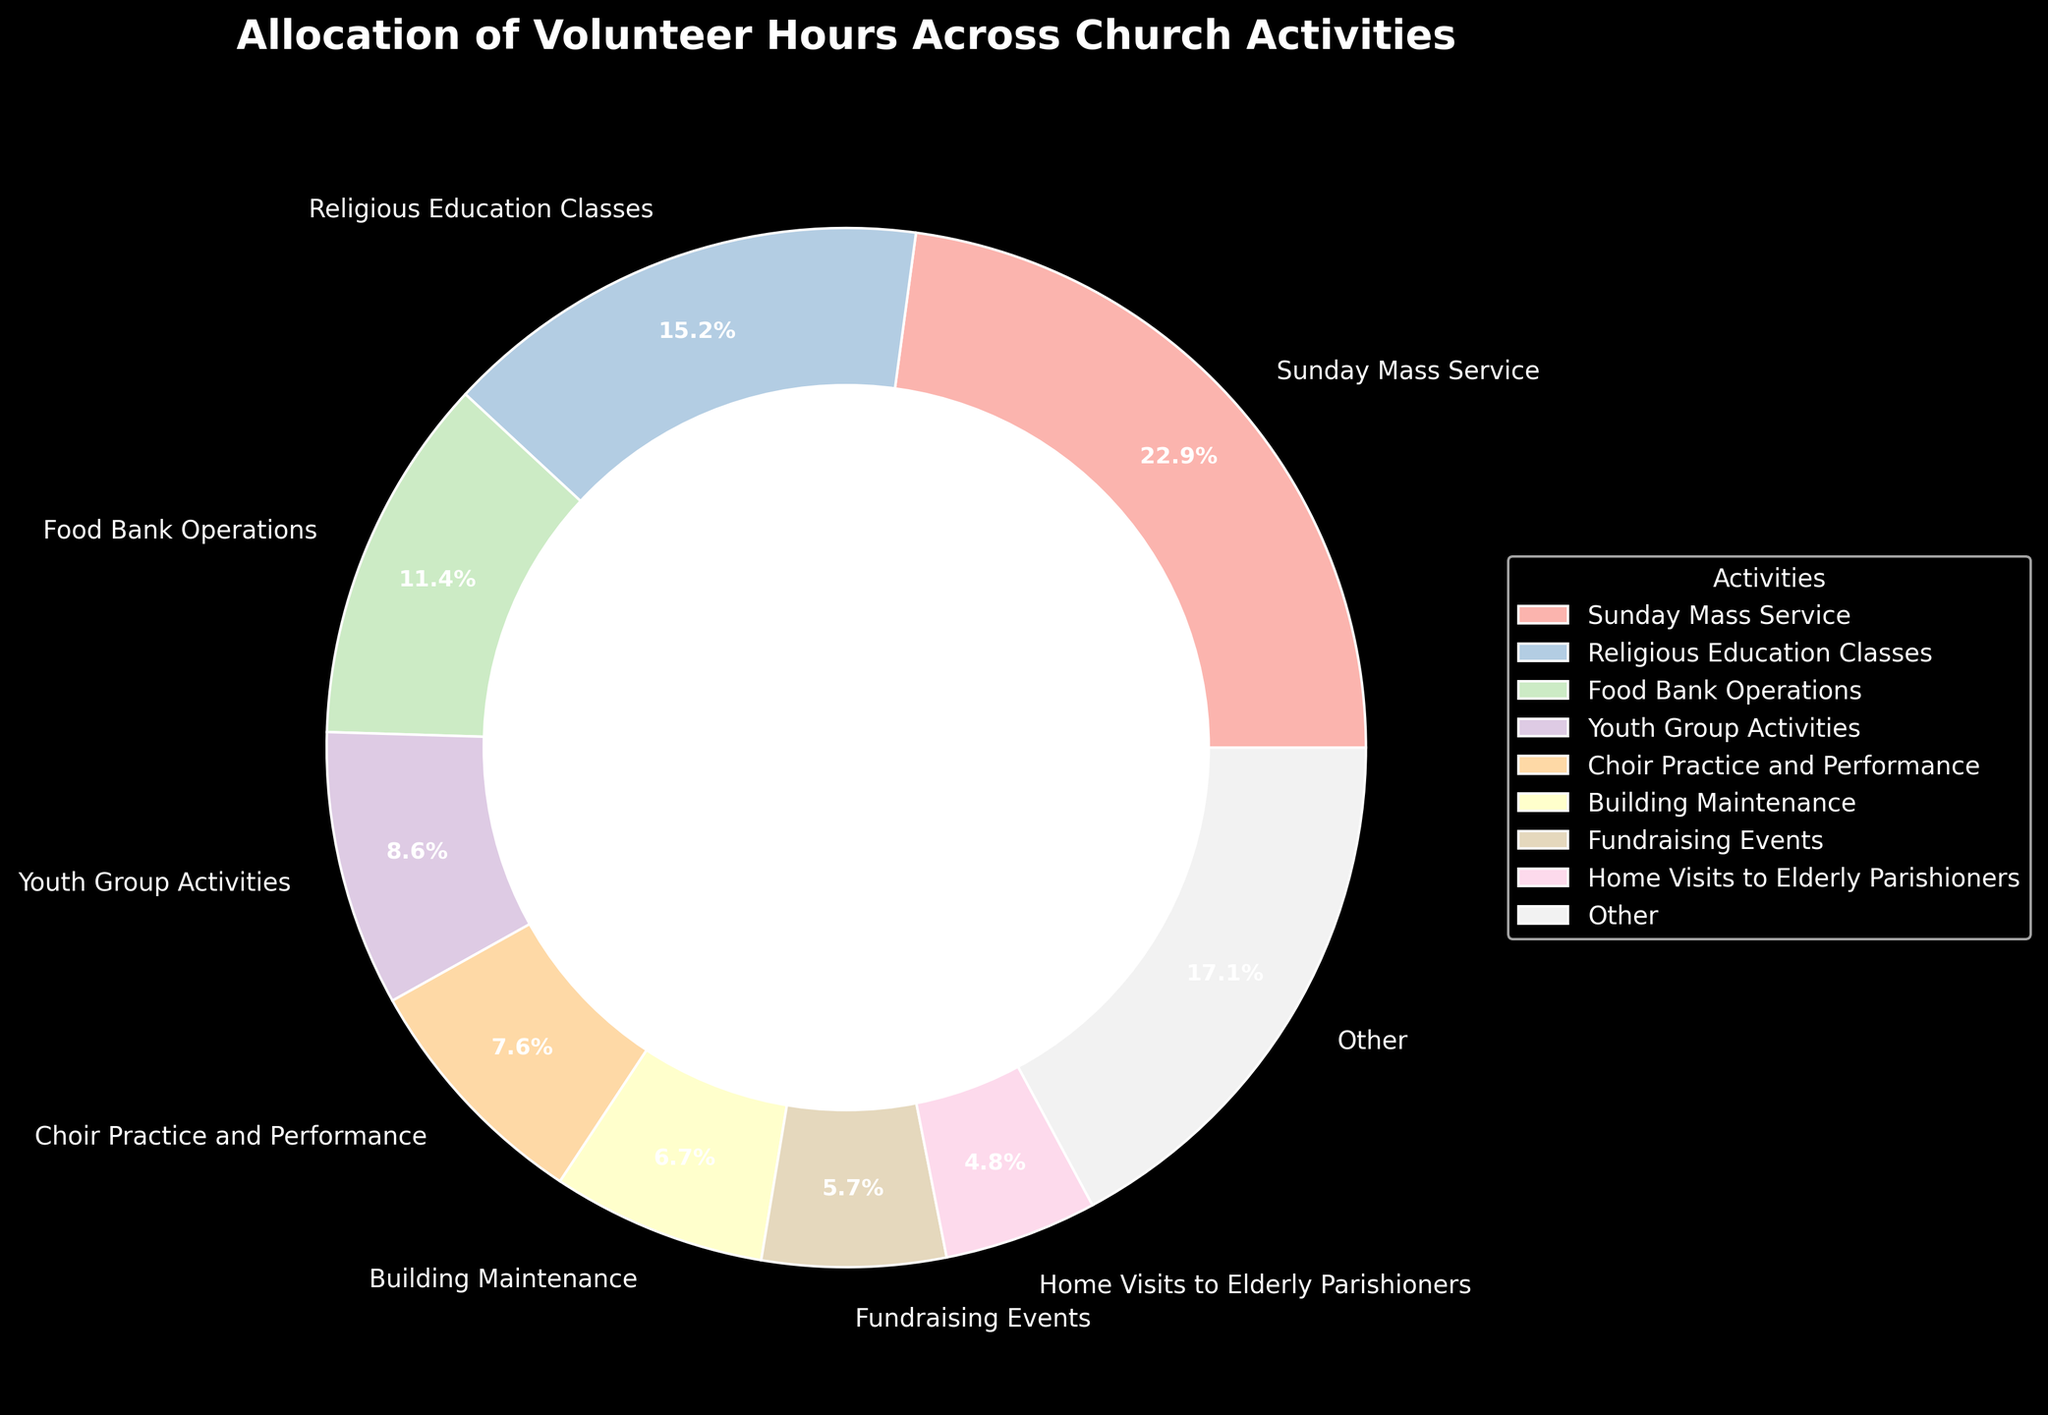Which activity receives the highest allocation of volunteer hours? By looking at the chart, the largest segment of the pie chart indicates the activity with the highest allocation.
Answer: Sunday Mass Service What percentage of total volunteer hours is allocated to Food Bank Operations? By referring to the label on the Food Bank Operations segment, we can directly see the percentage.
Answer: 12.8% How many activities are included under the 'Other' category? The 'Other' category aggregates the hours of all activities beyond the top 8. We check the number of activities listed in the legend and subtract 8.
Answer: 8 activities What is the combined percentage of volunteer hours allocated to Religious Education Classes and Youth Group Activities? Find the individual percentages from the chart, and sum them: 17.1% (Religious Education Classes) + 9.6% (Youth Group Activities).
Answer: 26.7% Which activity has the smallest slice on the pie chart? By visual inspection, the smallest slice represents the activity with the least volunteer hours.
Answer: Administrative Support Are the hours for Choir Practice and Performance greater than Fundraising Events? Compare the percentages or hours; the segment for Choir Practice and Performance is larger than the Fundraising Events segment.
Answer: Yes How much more percentage does Sunday Mass Service have compared to Bible Study Groups? Subtract the percentage of Bible Study Groups from Sunday Mass Service: 25.6% (Sunday Mass Service) - 4.3% (Bible Study Groups).
Answer: 21.3% What is the visual color used for Building Maintenance? Identify the segment representing Building Maintenance and describe its color.
Answer: Light blue How does the percentage for Home Visits to Elderly Parishioners compare to Coffee and Fellowship Hour? Compare the two percentages directly: 5.3% (Home Visits to Elderly Parishioners) vs. 2.6% (Coffee and Fellowship Hour).
Answer: Greater What percentage of total volunteer hours is allocated to the 'Other' category? By looking at the label on the 'Other' category segment, we can directly see the percentage.
Answer: 8.5% 